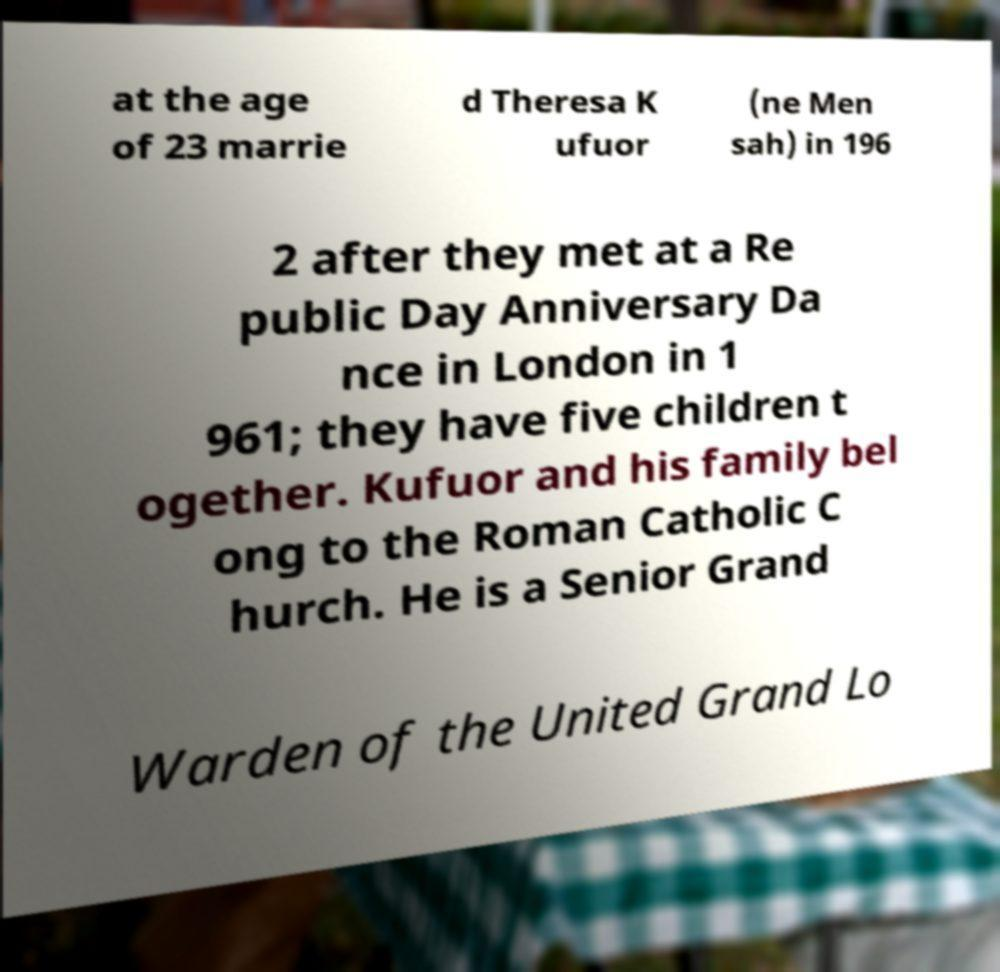Can you accurately transcribe the text from the provided image for me? at the age of 23 marrie d Theresa K ufuor (ne Men sah) in 196 2 after they met at a Re public Day Anniversary Da nce in London in 1 961; they have five children t ogether. Kufuor and his family bel ong to the Roman Catholic C hurch. He is a Senior Grand Warden of the United Grand Lo 